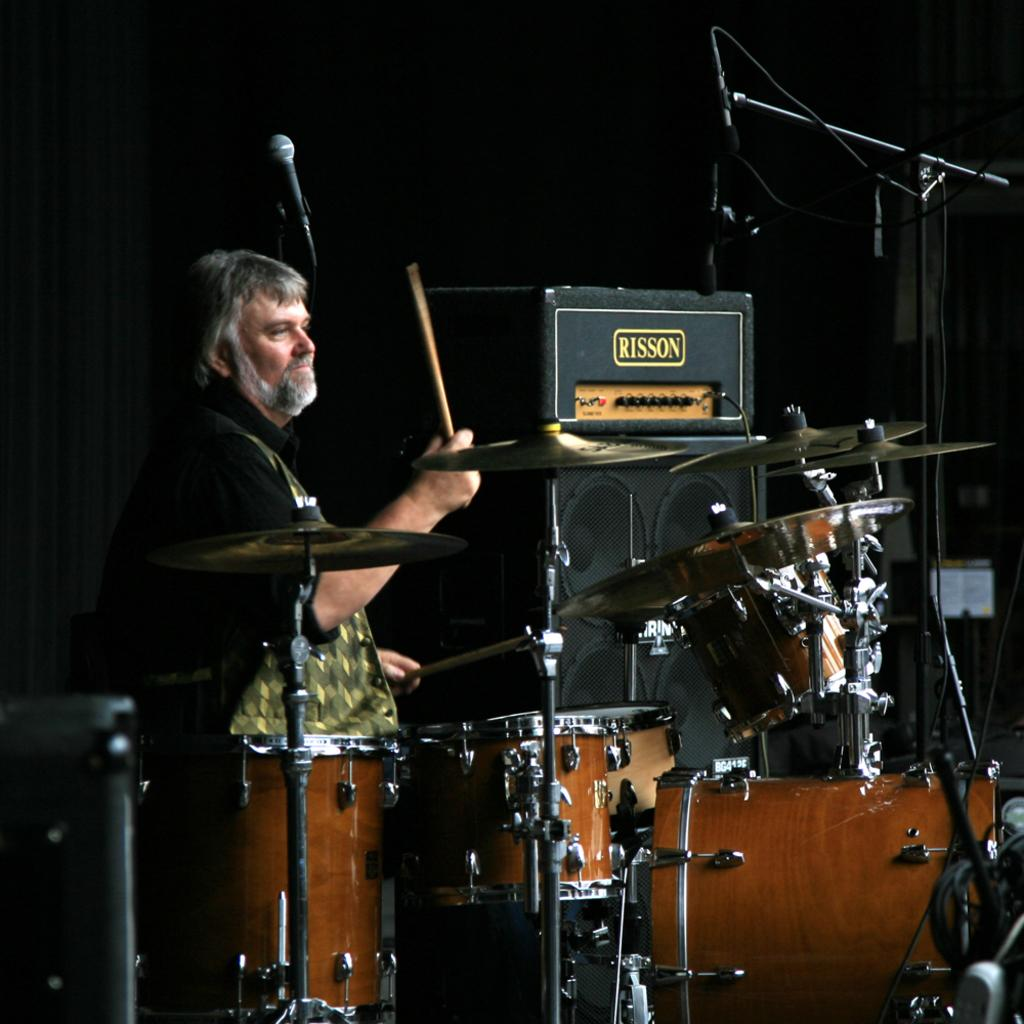What is the man in the image doing? The man is playing drums. What is the man using to play the drums? The man is using a wooden stick to play the drums. What type of cherries can be seen being measured by the man in the image? There are no cherries present in the image, and the man is not measuring anything. What type of medical equipment can be seen in the image? There is no medical equipment present in the image; it features a man playing drums with a wooden stick. 